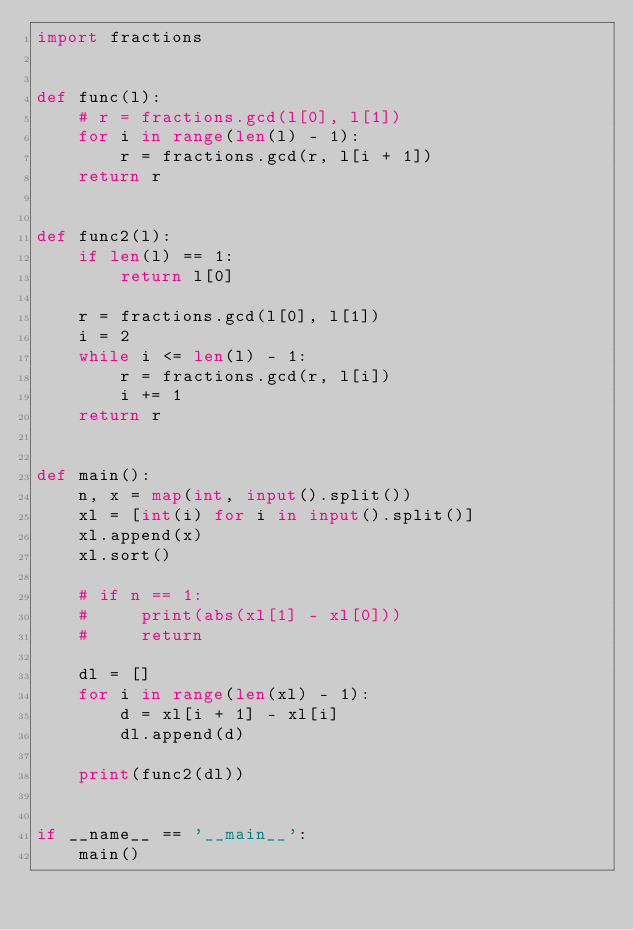<code> <loc_0><loc_0><loc_500><loc_500><_Python_>import fractions


def func(l):
    # r = fractions.gcd(l[0], l[1])
    for i in range(len(l) - 1):
        r = fractions.gcd(r, l[i + 1])
    return r


def func2(l):
    if len(l) == 1:
        return l[0]

    r = fractions.gcd(l[0], l[1])
    i = 2
    while i <= len(l) - 1:
        r = fractions.gcd(r, l[i])
        i += 1
    return r


def main():
    n, x = map(int, input().split())
    xl = [int(i) for i in input().split()]
    xl.append(x)
    xl.sort()

    # if n == 1:
    #     print(abs(xl[1] - xl[0]))
    #     return

    dl = []
    for i in range(len(xl) - 1):
        d = xl[i + 1] - xl[i]
        dl.append(d)

    print(func2(dl))


if __name__ == '__main__':
    main()
</code> 